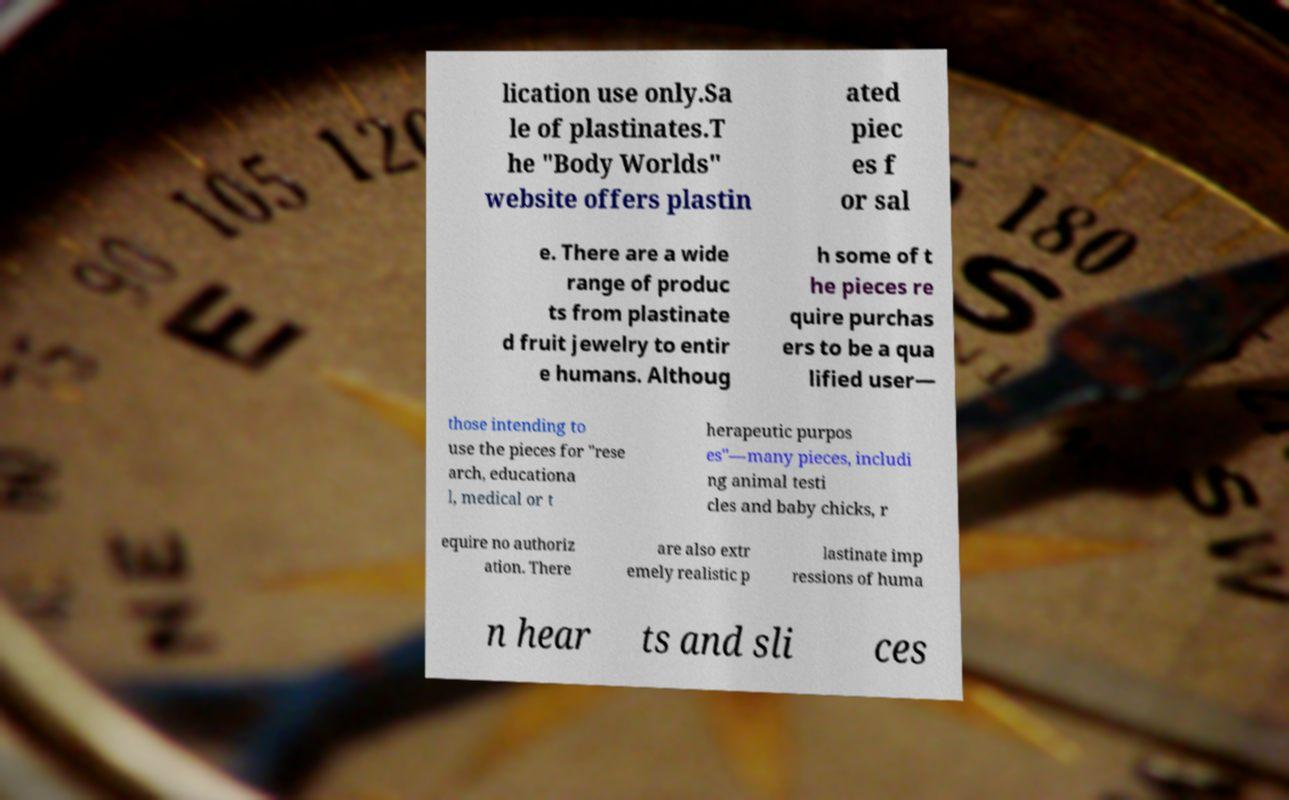Can you read and provide the text displayed in the image?This photo seems to have some interesting text. Can you extract and type it out for me? lication use only.Sa le of plastinates.T he "Body Worlds" website offers plastin ated piec es f or sal e. There are a wide range of produc ts from plastinate d fruit jewelry to entir e humans. Althoug h some of t he pieces re quire purchas ers to be a qua lified user— those intending to use the pieces for "rese arch, educationa l, medical or t herapeutic purpos es"—many pieces, includi ng animal testi cles and baby chicks, r equire no authoriz ation. There are also extr emely realistic p lastinate imp ressions of huma n hear ts and sli ces 